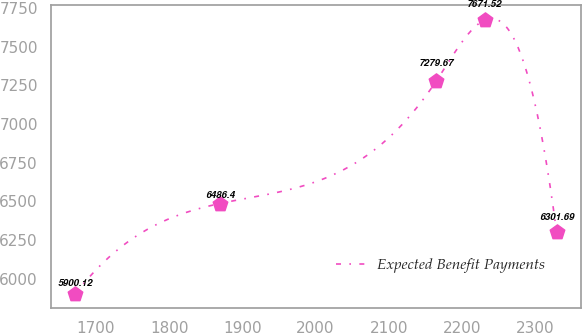Convert chart. <chart><loc_0><loc_0><loc_500><loc_500><line_chart><ecel><fcel>Expected Benefit Payments<nl><fcel>1671.4<fcel>5900.12<nl><fcel>1868.96<fcel>6486.4<nl><fcel>2165.18<fcel>7279.67<nl><fcel>2230.99<fcel>7671.52<nl><fcel>2329.47<fcel>6301.69<nl></chart> 